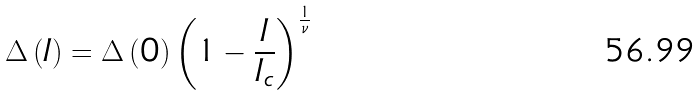<formula> <loc_0><loc_0><loc_500><loc_500>\Delta \left ( I \right ) = \Delta \left ( 0 \right ) \left ( 1 - \frac { I } { I _ { c } } \right ) ^ { \frac { 1 } { \nu } }</formula> 